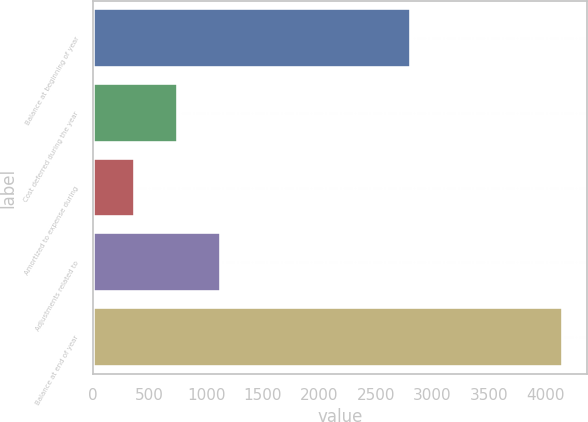Convert chart. <chart><loc_0><loc_0><loc_500><loc_500><bar_chart><fcel>Balance at beginning of year<fcel>Cost deferred during the year<fcel>Amortized to expense during<fcel>Adjustments related to<fcel>Balance at end of year<nl><fcel>2810.1<fcel>751.63<fcel>373.7<fcel>1129.56<fcel>4153<nl></chart> 